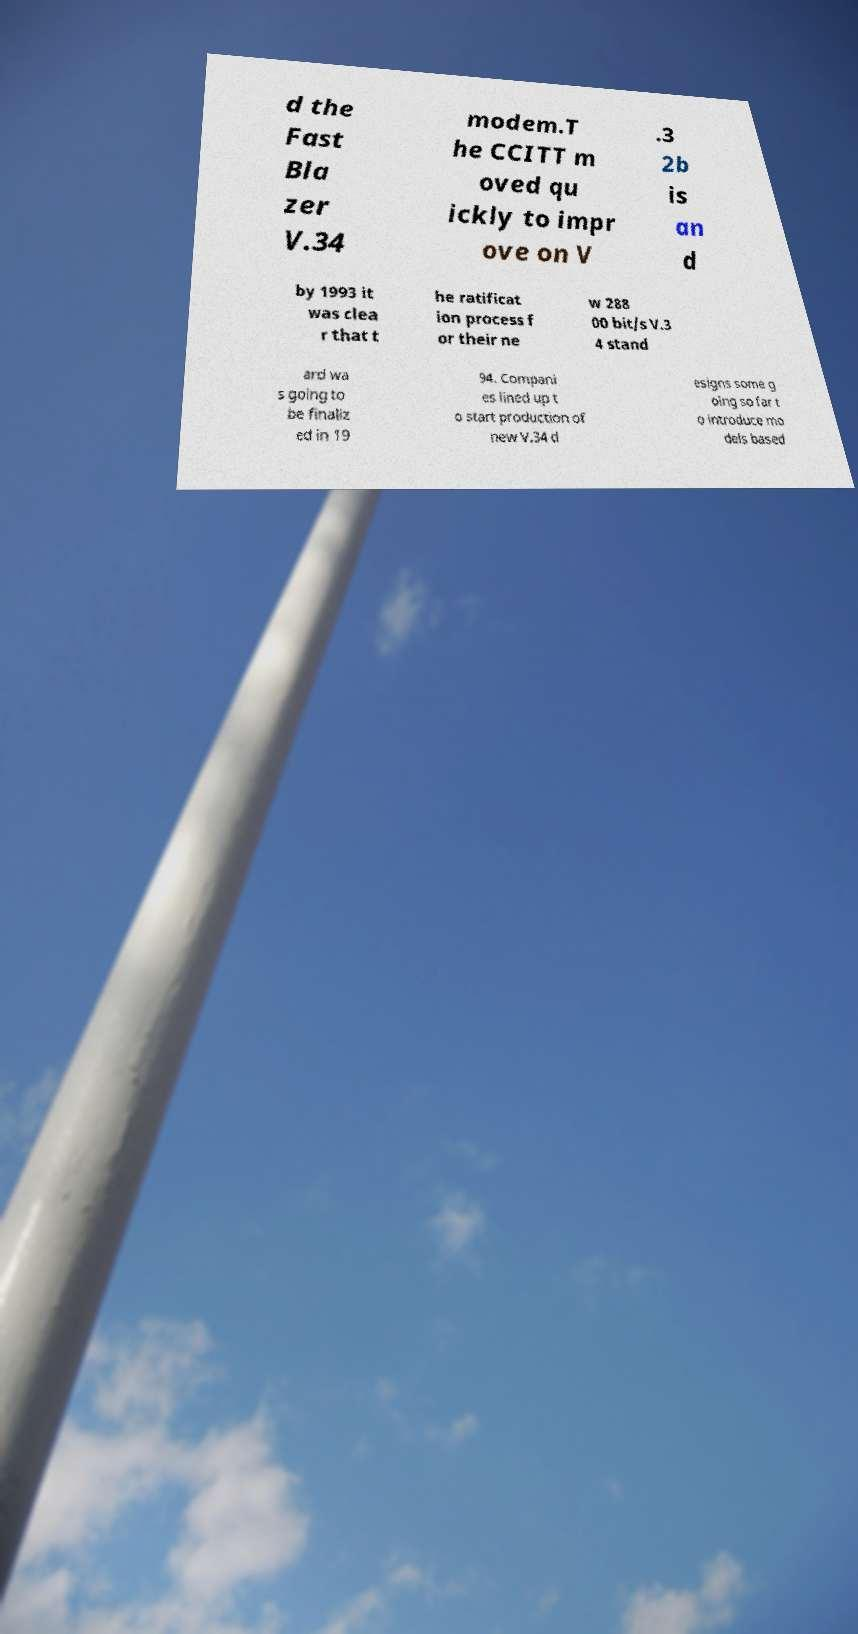Could you extract and type out the text from this image? d the Fast Bla zer V.34 modem.T he CCITT m oved qu ickly to impr ove on V .3 2b is an d by 1993 it was clea r that t he ratificat ion process f or their ne w 288 00 bit/s V.3 4 stand ard wa s going to be finaliz ed in 19 94. Compani es lined up t o start production of new V.34 d esigns some g oing so far t o introduce mo dels based 